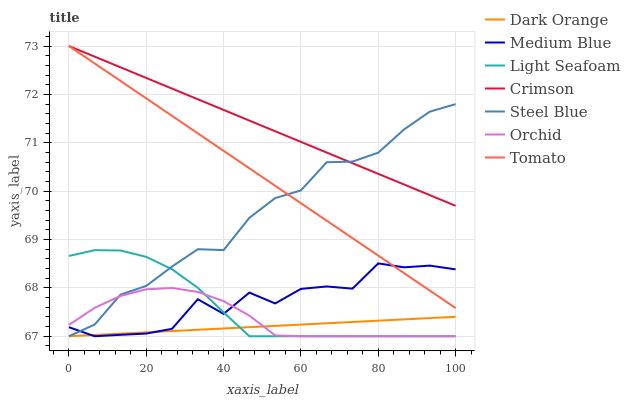Does Dark Orange have the minimum area under the curve?
Answer yes or no. Yes. Does Crimson have the maximum area under the curve?
Answer yes or no. Yes. Does Medium Blue have the minimum area under the curve?
Answer yes or no. No. Does Medium Blue have the maximum area under the curve?
Answer yes or no. No. Is Crimson the smoothest?
Answer yes or no. Yes. Is Medium Blue the roughest?
Answer yes or no. Yes. Is Dark Orange the smoothest?
Answer yes or no. No. Is Dark Orange the roughest?
Answer yes or no. No. Does Dark Orange have the lowest value?
Answer yes or no. Yes. Does Crimson have the lowest value?
Answer yes or no. No. Does Crimson have the highest value?
Answer yes or no. Yes. Does Medium Blue have the highest value?
Answer yes or no. No. Is Orchid less than Tomato?
Answer yes or no. Yes. Is Crimson greater than Dark Orange?
Answer yes or no. Yes. Does Steel Blue intersect Light Seafoam?
Answer yes or no. Yes. Is Steel Blue less than Light Seafoam?
Answer yes or no. No. Is Steel Blue greater than Light Seafoam?
Answer yes or no. No. Does Orchid intersect Tomato?
Answer yes or no. No. 